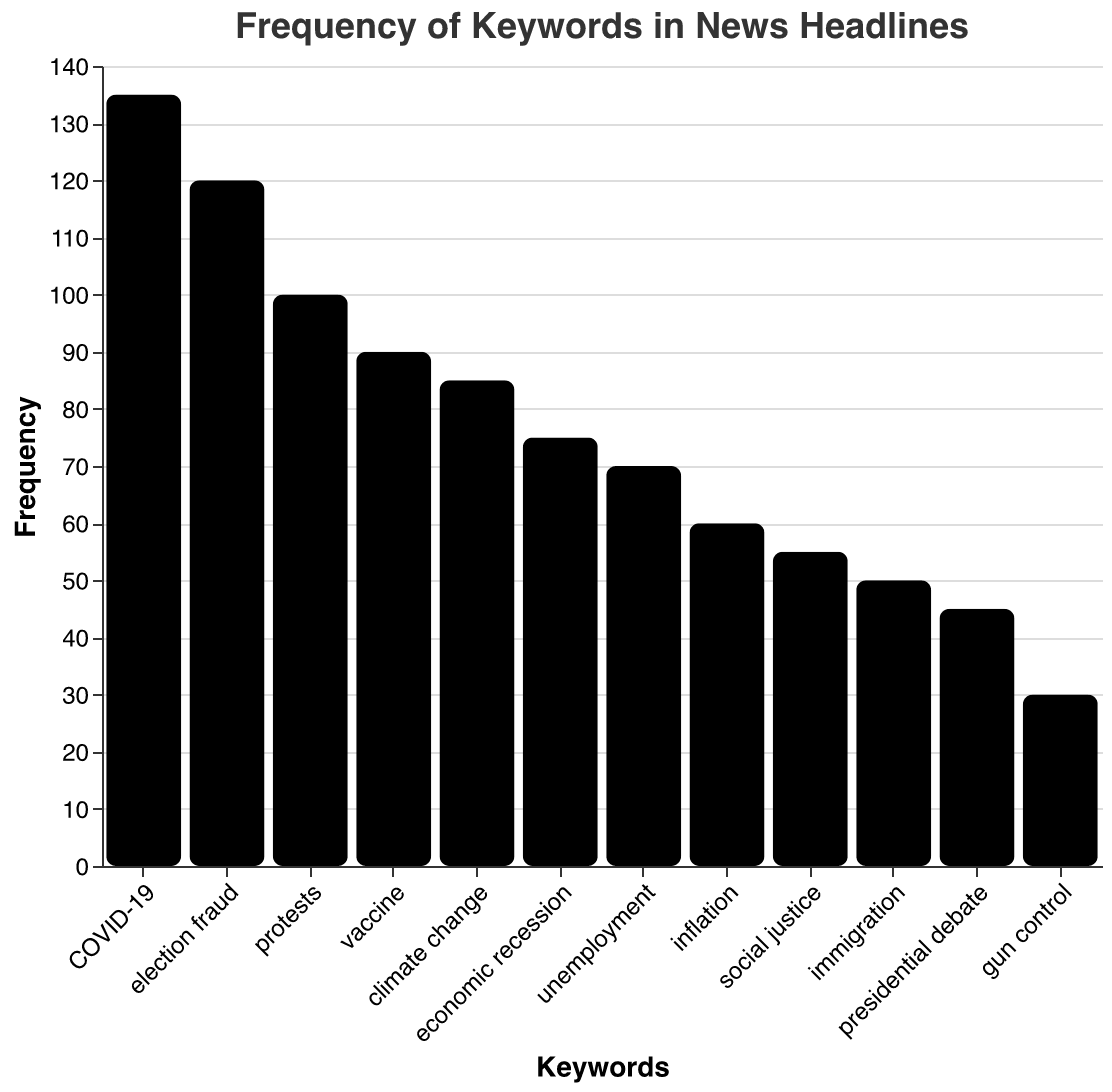What's the title of the figure? The title of the figure is usually displayed prominently at the top. In this case, the title is clearly stated.
Answer: Frequency of Keywords in News Headlines What is the frequency of the keyword "COVID-19"? To find the frequency of "COVID-19," you look at the bar associated with "COVID-19" and read the value on the y-axis.
Answer: 135 Which keyword has the highest frequency? By comparing the lengths of all the bars, the bar representing "COVID-19" is the highest, indicating it has the highest frequency.
Answer: COVID-19 What is the frequency difference between "vaccine" and "election fraud"? To find the difference, subtract the frequency of "vaccine" from "election fraud." The frequency for "election fraud" is 120 and for "vaccine" is 90.
Answer: 30 What is the total frequency for "climate change," "social justice," and "gun control" combined? Add the frequencies of these keywords: 85 ("climate change") + 55 ("social justice") + 30 ("gun control"). The sum is calculated to determine the total frequency.
Answer: 170 Which keywords have a frequency of less than 50? Keywords with frequencies less than 50 include "immigration," "presidential debate," and "gun control."
Answer: Immigration, Presidential Debate, Gun Control How many keywords have a frequency greater than 100? To find this, count the number of bars with a height that corresponds to a frequency greater than 100. "Election fraud," "COVID-19," and "protests" are greater than 100.
Answer: 3 What is the average frequency of all the keywords? Add up all frequencies and divide by the number of keywords: (120 + 85 + 135 + 75 + 55 + 90 + 100 + 70 + 60 + 50 + 45 + 30) / 12. Calculate the sum and then the average.
Answer: 77.5 